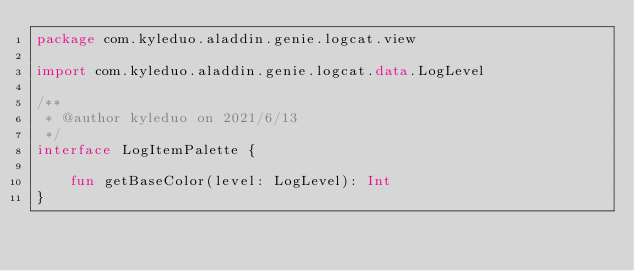<code> <loc_0><loc_0><loc_500><loc_500><_Kotlin_>package com.kyleduo.aladdin.genie.logcat.view

import com.kyleduo.aladdin.genie.logcat.data.LogLevel

/**
 * @author kyleduo on 2021/6/13
 */
interface LogItemPalette {

    fun getBaseColor(level: LogLevel): Int
}</code> 